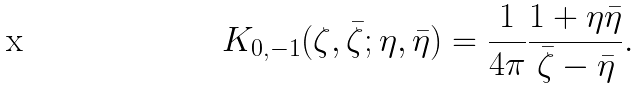Convert formula to latex. <formula><loc_0><loc_0><loc_500><loc_500>K _ { 0 , - 1 } ( \zeta , \bar { \zeta } ; \eta , \bar { \eta } ) = \frac { 1 } { 4 \pi } \frac { 1 + \eta \bar { \eta } } { \bar { \zeta } - \bar { \eta } } .</formula> 